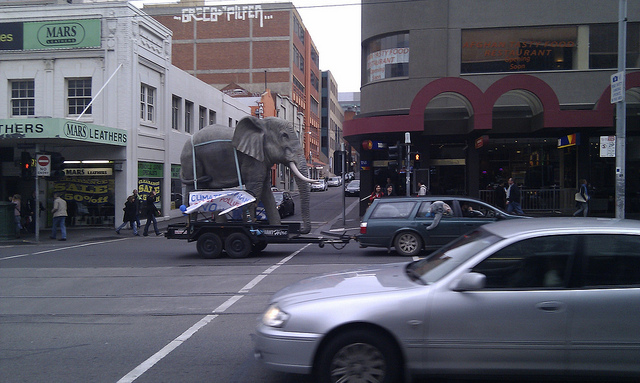Read all the text in this image. LEATHERS MARS HERS MARS MARS 85 SAJS 50% cum4 